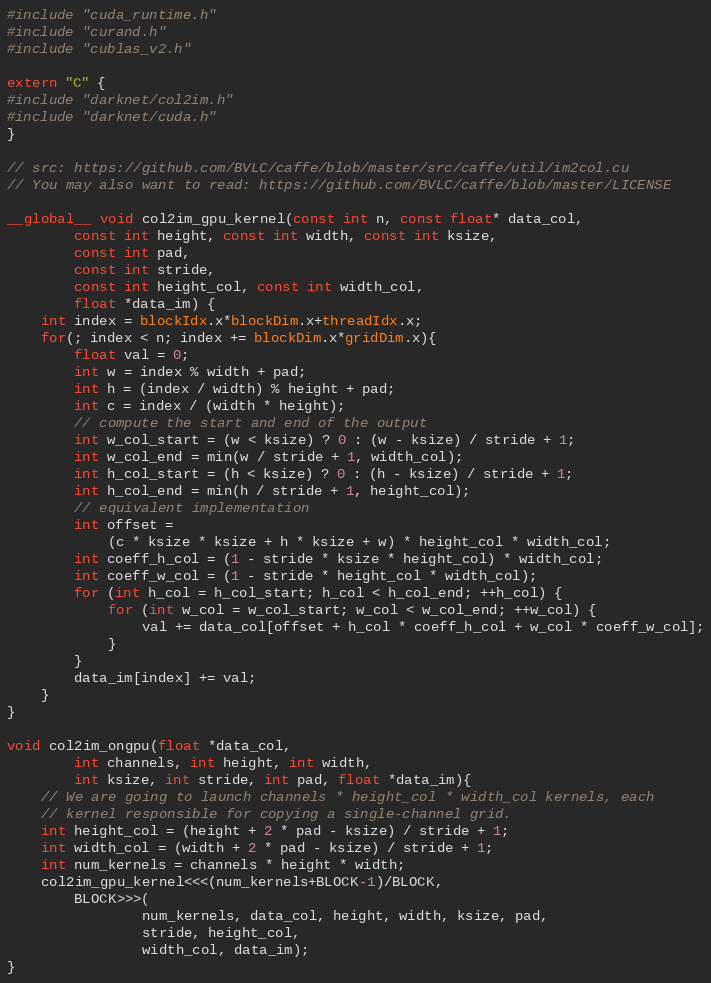<code> <loc_0><loc_0><loc_500><loc_500><_Cuda_>#include "cuda_runtime.h"
#include "curand.h"
#include "cublas_v2.h"

extern "C" {
#include "darknet/col2im.h"
#include "darknet/cuda.h"
}

// src: https://github.com/BVLC/caffe/blob/master/src/caffe/util/im2col.cu
// You may also want to read: https://github.com/BVLC/caffe/blob/master/LICENSE

__global__ void col2im_gpu_kernel(const int n, const float* data_col,
        const int height, const int width, const int ksize,
        const int pad,
        const int stride,
        const int height_col, const int width_col,
        float *data_im) {
    int index = blockIdx.x*blockDim.x+threadIdx.x;
    for(; index < n; index += blockDim.x*gridDim.x){
        float val = 0;
        int w = index % width + pad;
        int h = (index / width) % height + pad;
        int c = index / (width * height);
        // compute the start and end of the output
        int w_col_start = (w < ksize) ? 0 : (w - ksize) / stride + 1;
        int w_col_end = min(w / stride + 1, width_col);
        int h_col_start = (h < ksize) ? 0 : (h - ksize) / stride + 1;
        int h_col_end = min(h / stride + 1, height_col);
        // equivalent implementation
        int offset =
            (c * ksize * ksize + h * ksize + w) * height_col * width_col;
        int coeff_h_col = (1 - stride * ksize * height_col) * width_col;
        int coeff_w_col = (1 - stride * height_col * width_col);
        for (int h_col = h_col_start; h_col < h_col_end; ++h_col) {
            for (int w_col = w_col_start; w_col < w_col_end; ++w_col) {
                val += data_col[offset + h_col * coeff_h_col + w_col * coeff_w_col];
            }
        }
        data_im[index] += val;
    }
}

void col2im_ongpu(float *data_col,
        int channels, int height, int width,
        int ksize, int stride, int pad, float *data_im){
    // We are going to launch channels * height_col * width_col kernels, each
    // kernel responsible for copying a single-channel grid.
    int height_col = (height + 2 * pad - ksize) / stride + 1;
    int width_col = (width + 2 * pad - ksize) / stride + 1;
    int num_kernels = channels * height * width;
    col2im_gpu_kernel<<<(num_kernels+BLOCK-1)/BLOCK,
        BLOCK>>>(
                num_kernels, data_col, height, width, ksize, pad,
                stride, height_col,
                width_col, data_im);
}

</code> 